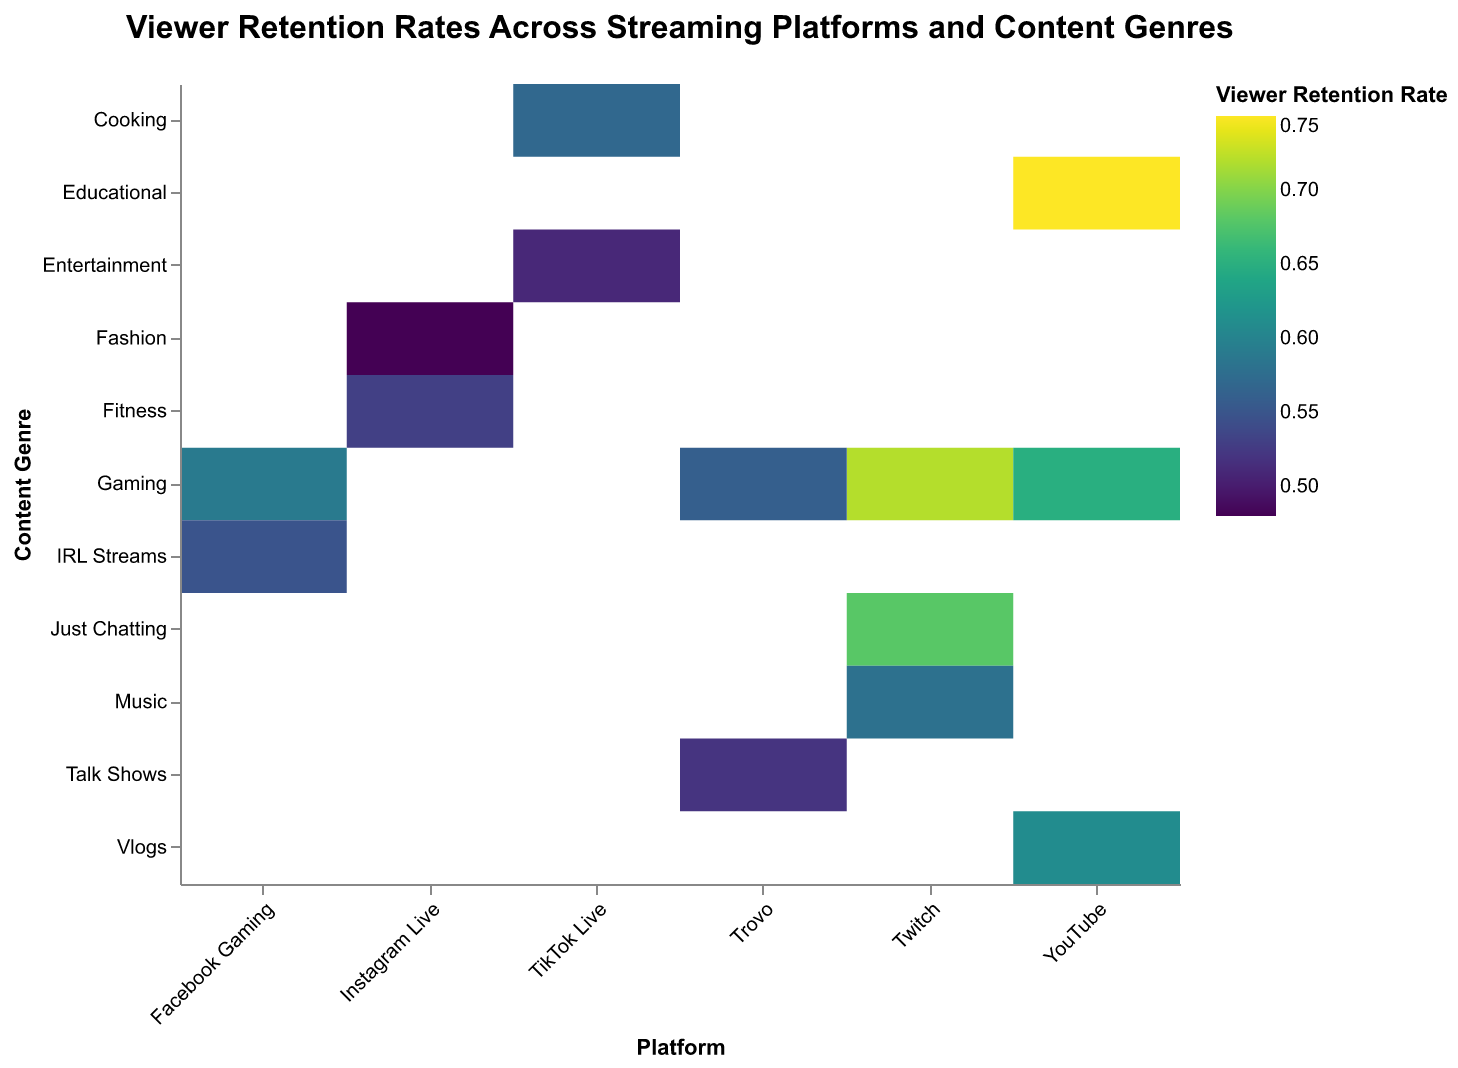What is the title of the figure? The title is located at the top of the plot, clearly stating what the figure represents.
Answer: "Viewer Retention Rates Across Streaming Platforms and Content Genres" How is the Viewer Retention Rate represented in the plot? The Viewer Retention Rate is represented by the color of the rectangles, with different shades indicating different rates. There is also a text value inside each rectangle showing the exact Viewer Retention Rate.
Answer: By color and text Which platform has the highest Viewer Retention Rate for any content genre? By observing the color scale and text values within the rectangles, the highest rate is 0.75 for YouTube's Educational content.
Answer: YouTube's Educational content What is the Viewer Retention Rate for TikTok Live's Entertainment genre? Locate the rectangle corresponding to TikTok Live and Entertainment genre, then read the Viewer Retention Rate displayed.
Answer: 0.51 Compare the Viewer Retention Rates of Twitch's Gaming and YouTube's Gaming content genres. Which is higher? Look at the rectangles for Twitch's Gaming and YouTube's Gaming genres and compare the Viewer Retention Rates written inside. Twitch's Gaming has 0.72, while YouTube's Gaming has 0.65.
Answer: Twitch's Gaming Which platform has the lowest Viewer Retention Rate and for what content genre? By scanning through the color gradient and text values, the lowest rate is 0.48 for Instagram Live's Fashion genre.
Answer: Instagram Live's Fashion Calculate the average Viewer Retention Rate for Twitch across all its content genres. Add up the Viewer Retention Rates for Twitch's genres (0.72 + 0.68 + 0.58) and divide by the number of content genres (3).
Answer: (0.72 + 0.68 + 0.58) / 3 = 0.66 How many content genres are analyzed in this figure? Count the unique content genres listed on the y-axis of the plot.
Answer: 9 Which content genre has the highest Viewer Retention Rate overall, and which platform is it associated with? Identify the highest Viewer Retention Rate value and find the content genre and platform associated with it. The highest rate is 0.75 for Educational content on YouTube.
Answer: YouTube's Educational content What is the difference in Viewer Retention Rates between Facebook Gaming's Gaming genre and IRL Streams? Read the rates for both genres under Facebook Gaming (0.59 for Gaming and 0.55 for IRL Streams), then calculate the difference.
Answer: 0.59 - 0.55 = 0.04 